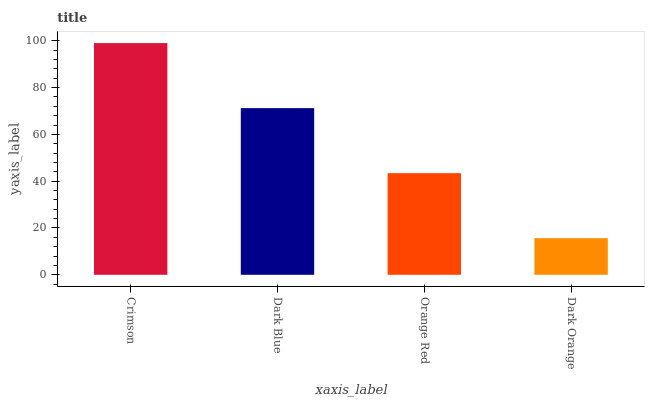Is Dark Orange the minimum?
Answer yes or no. Yes. Is Crimson the maximum?
Answer yes or no. Yes. Is Dark Blue the minimum?
Answer yes or no. No. Is Dark Blue the maximum?
Answer yes or no. No. Is Crimson greater than Dark Blue?
Answer yes or no. Yes. Is Dark Blue less than Crimson?
Answer yes or no. Yes. Is Dark Blue greater than Crimson?
Answer yes or no. No. Is Crimson less than Dark Blue?
Answer yes or no. No. Is Dark Blue the high median?
Answer yes or no. Yes. Is Orange Red the low median?
Answer yes or no. Yes. Is Orange Red the high median?
Answer yes or no. No. Is Dark Orange the low median?
Answer yes or no. No. 